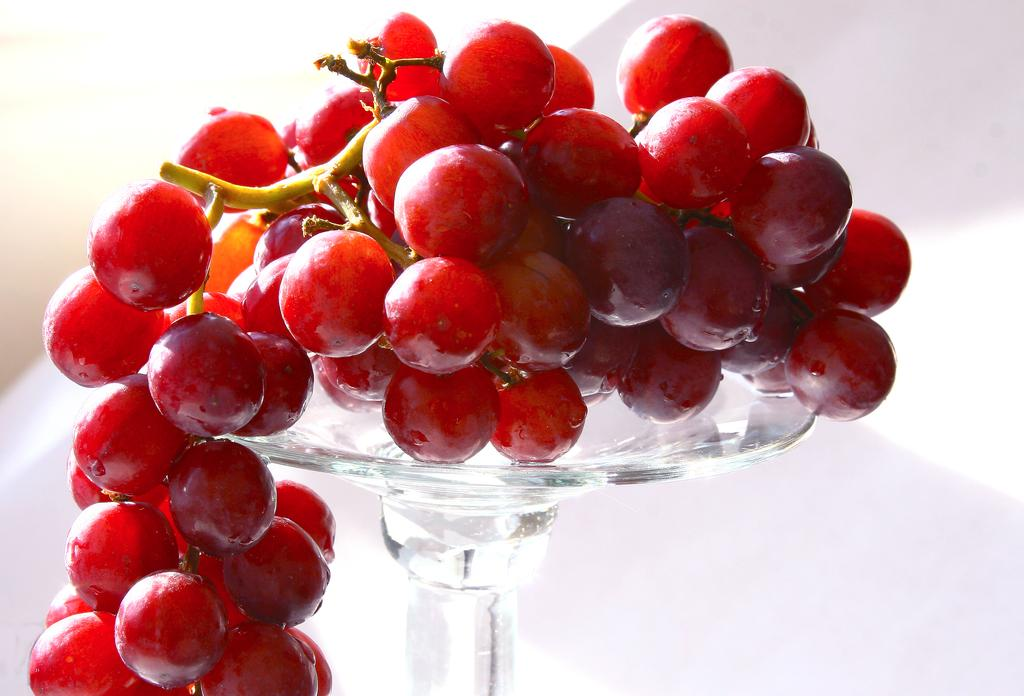What type of fruit is present in the image? There are grapes in the image. What color are the grapes? The grapes are red in color. Where are the grapes placed in the image? The grapes are placed on a table. What type of skirt is the grandmother wearing in the image? There is no grandmother or skirt present in the image. How does the grape smile at the camera in the image? Grapes do not have the ability to smile or interact with a camera, as they are inanimate objects. 